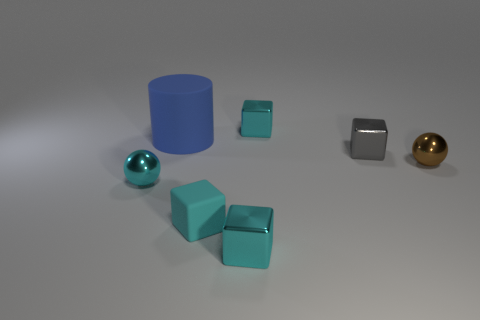Subtract all cyan cubes. How many were subtracted if there are2cyan cubes left? 1 Subtract all cubes. How many objects are left? 3 Subtract 2 spheres. How many spheres are left? 0 Subtract all cyan cylinders. Subtract all red balls. How many cylinders are left? 1 Subtract all yellow balls. How many cyan cubes are left? 3 Subtract all small purple blocks. Subtract all matte blocks. How many objects are left? 6 Add 5 small gray things. How many small gray things are left? 6 Add 1 gray shiny cubes. How many gray shiny cubes exist? 2 Add 2 blue objects. How many objects exist? 9 Subtract all brown spheres. How many spheres are left? 1 